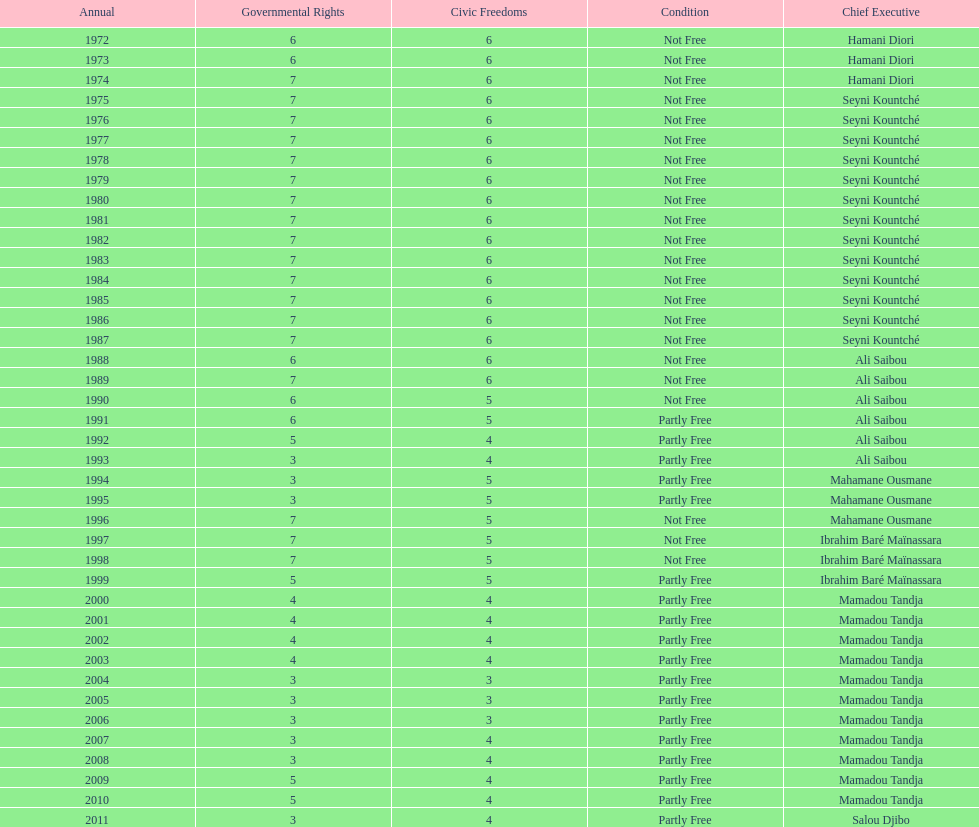Could you parse the entire table? {'header': ['Annual', 'Governmental Rights', 'Civic Freedoms', 'Condition', 'Chief Executive'], 'rows': [['1972', '6', '6', 'Not Free', 'Hamani Diori'], ['1973', '6', '6', 'Not Free', 'Hamani Diori'], ['1974', '7', '6', 'Not Free', 'Hamani Diori'], ['1975', '7', '6', 'Not Free', 'Seyni Kountché'], ['1976', '7', '6', 'Not Free', 'Seyni Kountché'], ['1977', '7', '6', 'Not Free', 'Seyni Kountché'], ['1978', '7', '6', 'Not Free', 'Seyni Kountché'], ['1979', '7', '6', 'Not Free', 'Seyni Kountché'], ['1980', '7', '6', 'Not Free', 'Seyni Kountché'], ['1981', '7', '6', 'Not Free', 'Seyni Kountché'], ['1982', '7', '6', 'Not Free', 'Seyni Kountché'], ['1983', '7', '6', 'Not Free', 'Seyni Kountché'], ['1984', '7', '6', 'Not Free', 'Seyni Kountché'], ['1985', '7', '6', 'Not Free', 'Seyni Kountché'], ['1986', '7', '6', 'Not Free', 'Seyni Kountché'], ['1987', '7', '6', 'Not Free', 'Seyni Kountché'], ['1988', '6', '6', 'Not Free', 'Ali Saibou'], ['1989', '7', '6', 'Not Free', 'Ali Saibou'], ['1990', '6', '5', 'Not Free', 'Ali Saibou'], ['1991', '6', '5', 'Partly Free', 'Ali Saibou'], ['1992', '5', '4', 'Partly Free', 'Ali Saibou'], ['1993', '3', '4', 'Partly Free', 'Ali Saibou'], ['1994', '3', '5', 'Partly Free', 'Mahamane Ousmane'], ['1995', '3', '5', 'Partly Free', 'Mahamane Ousmane'], ['1996', '7', '5', 'Not Free', 'Mahamane Ousmane'], ['1997', '7', '5', 'Not Free', 'Ibrahim Baré Maïnassara'], ['1998', '7', '5', 'Not Free', 'Ibrahim Baré Maïnassara'], ['1999', '5', '5', 'Partly Free', 'Ibrahim Baré Maïnassara'], ['2000', '4', '4', 'Partly Free', 'Mamadou Tandja'], ['2001', '4', '4', 'Partly Free', 'Mamadou Tandja'], ['2002', '4', '4', 'Partly Free', 'Mamadou Tandja'], ['2003', '4', '4', 'Partly Free', 'Mamadou Tandja'], ['2004', '3', '3', 'Partly Free', 'Mamadou Tandja'], ['2005', '3', '3', 'Partly Free', 'Mamadou Tandja'], ['2006', '3', '3', 'Partly Free', 'Mamadou Tandja'], ['2007', '3', '4', 'Partly Free', 'Mamadou Tandja'], ['2008', '3', '4', 'Partly Free', 'Mamadou Tandja'], ['2009', '5', '4', 'Partly Free', 'Mamadou Tandja'], ['2010', '5', '4', 'Partly Free', 'Mamadou Tandja'], ['2011', '3', '4', 'Partly Free', 'Salou Djibo']]} How many years was it before the first partly free status? 18. 